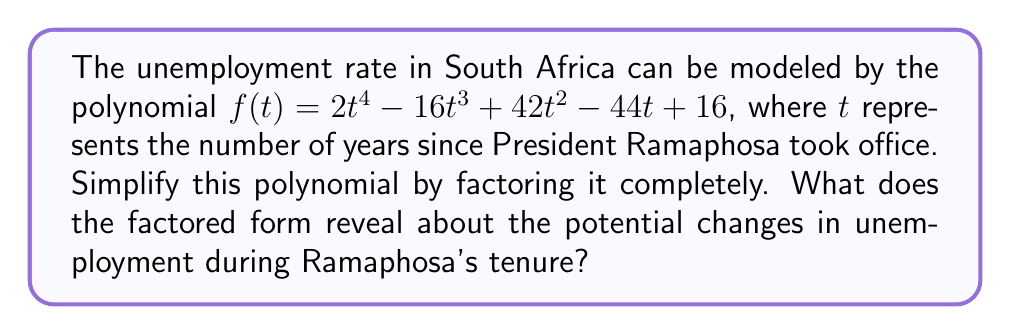Show me your answer to this math problem. Let's approach this step-by-step:

1) First, we need to factor out the greatest common factor (GCF) if possible. In this case, there is no common factor for all terms.

2) Next, we can try to identify if this is a perfect square trinomial or the difference of squares. It doesn't appear to be either.

3) Let's check if we can use the rational root theorem. The possible rational roots are the factors of the constant term: ±1, ±2, ±4, ±8, ±16.

4) Testing these values, we find that 2 is a root. So $(t-2)$ is a factor.

5) We can use polynomial long division to divide $f(t)$ by $(t-2)$:

   $$f(t) = (t-2)(2t^3 - 8t^2 + 26t - 8)$$

6) Now we need to factor the cubic polynomial $2t^3 - 8t^2 + 26t - 8$.

7) Testing the possible rational roots again, we find that 1 is a root of this cubic.

8) Dividing the cubic by $(t-1)$, we get:

   $$2t^3 - 8t^2 + 26t - 8 = (t-1)(2t^2 - 6t + 8)$$

9) The quadratic $2t^2 - 6t + 8$ can be factored as $2(t^2 - 3t + 4)$.

10) The quadratic $t^2 - 3t + 4$ doesn't have real roots, so it can't be factored further.

Therefore, the fully factored polynomial is:

$$f(t) = 2(t-2)(t-1)(t^2 - 3t + 4)$$

This factored form reveals that the unemployment rate could potentially reach its minimum values (roots of the polynomial) at 1 and 2 years after Ramaphosa took office. The quadratic factor suggests there might be more complex fluctuations in the unemployment rate over time.
Answer: $f(t) = 2(t-2)(t-1)(t^2 - 3t + 4)$ 